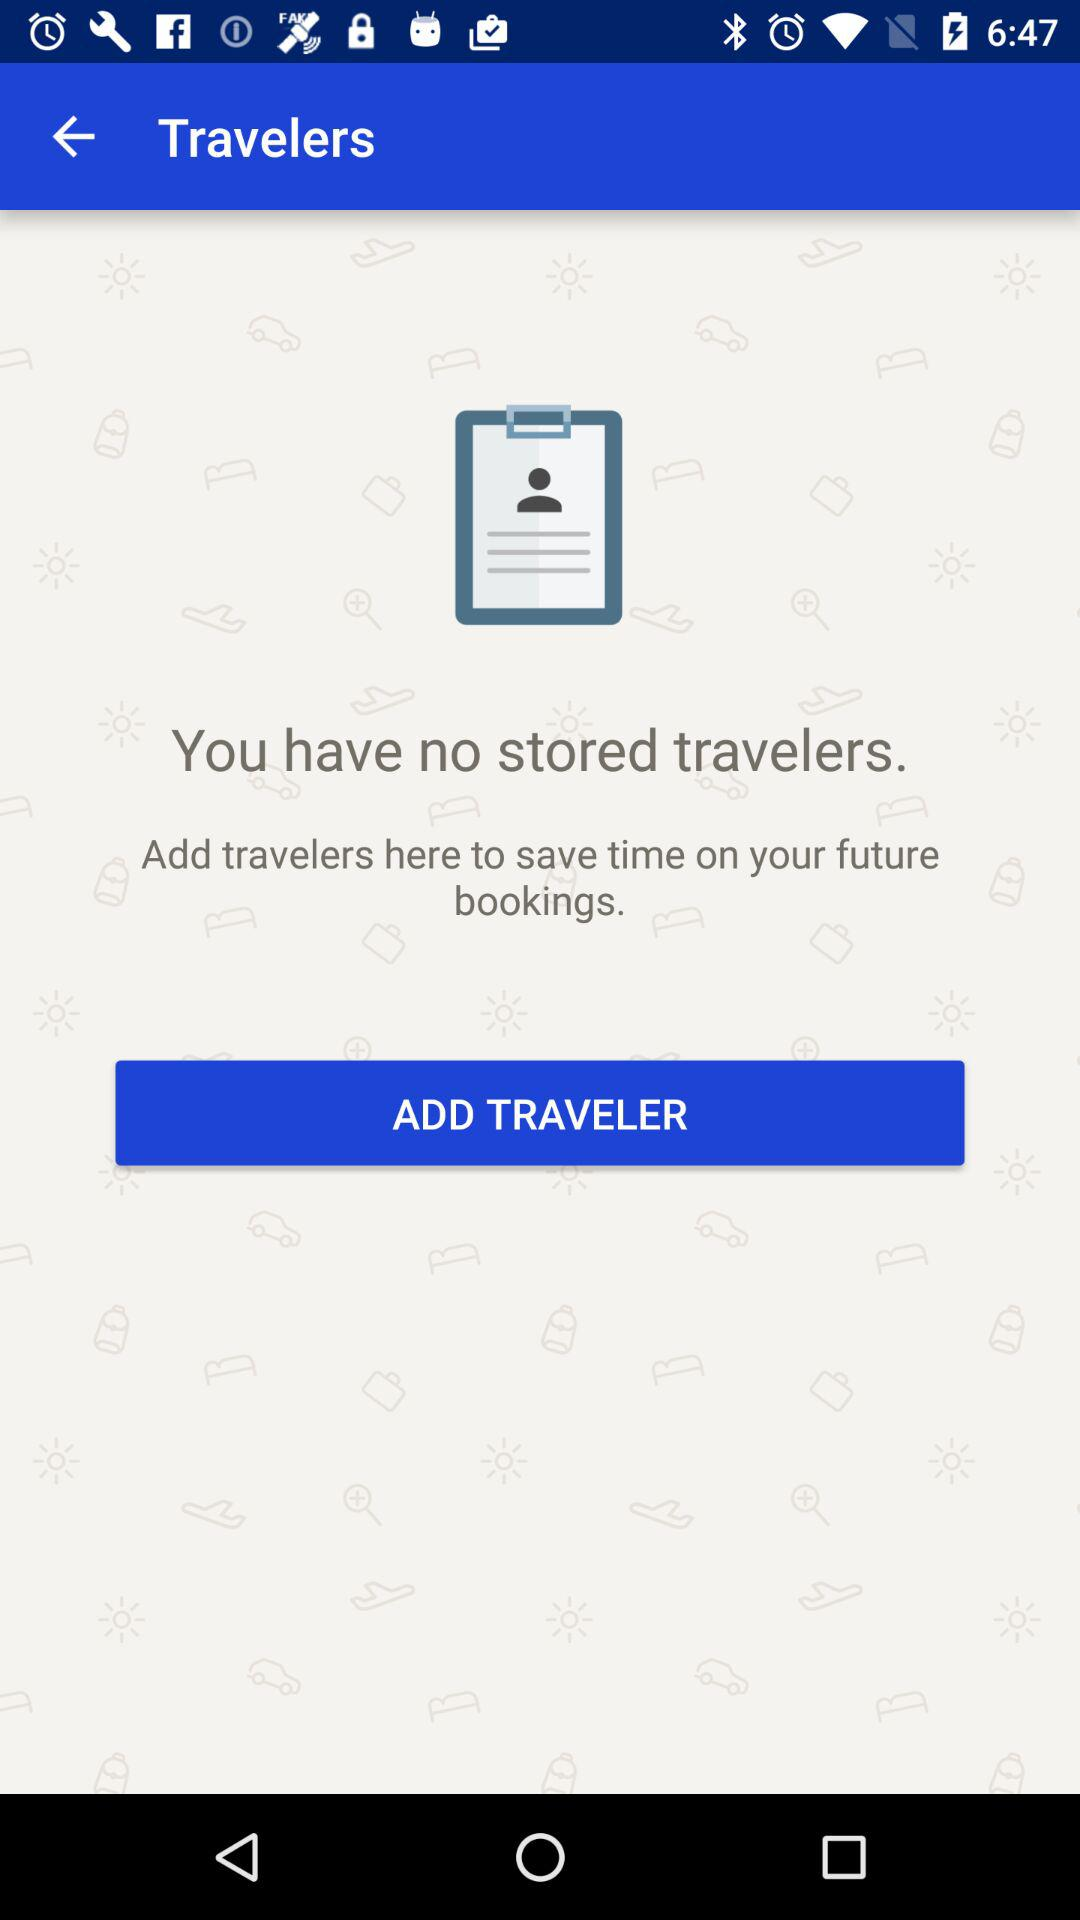How many stored travelers are there? There are no stored travelers. 